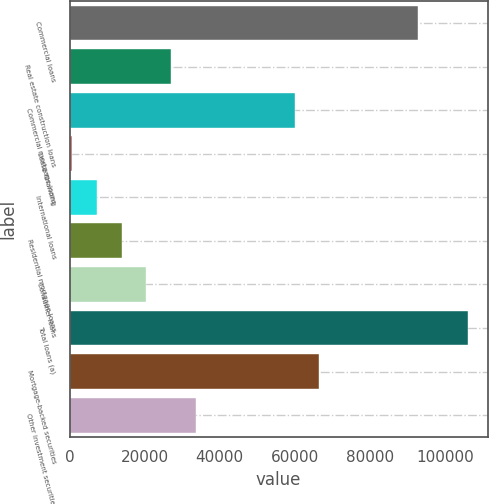Convert chart. <chart><loc_0><loc_0><loc_500><loc_500><bar_chart><fcel>Commercial loans<fcel>Real estate construction loans<fcel>Commercial mortgage loans<fcel>Lease financing<fcel>International loans<fcel>Residential mortgage loans<fcel>Consumer loans<fcel>Total loans (a)<fcel>Mortgage-backed securities<fcel>Other investment securities<nl><fcel>92889.4<fcel>27028.4<fcel>59958.9<fcel>684<fcel>7270.1<fcel>13856.2<fcel>20442.3<fcel>106062<fcel>66545<fcel>33614.5<nl></chart> 